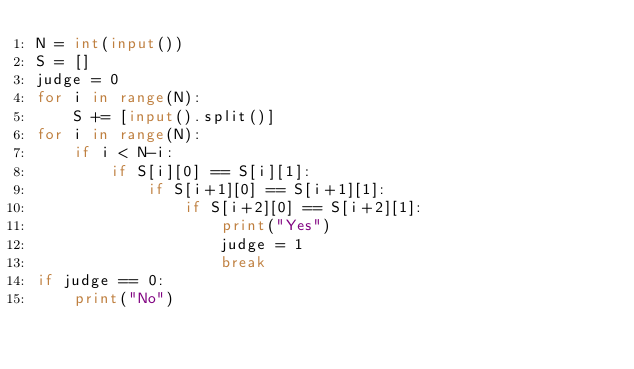Convert code to text. <code><loc_0><loc_0><loc_500><loc_500><_Python_>N = int(input())
S = []
judge = 0
for i in range(N):
    S += [input().split()]
for i in range(N):
    if i < N-i:
        if S[i][0] == S[i][1]:
            if S[i+1][0] == S[i+1][1]:
                if S[i+2][0] == S[i+2][1]:
                    print("Yes")
                    judge = 1
                    break
if judge == 0:
    print("No")</code> 